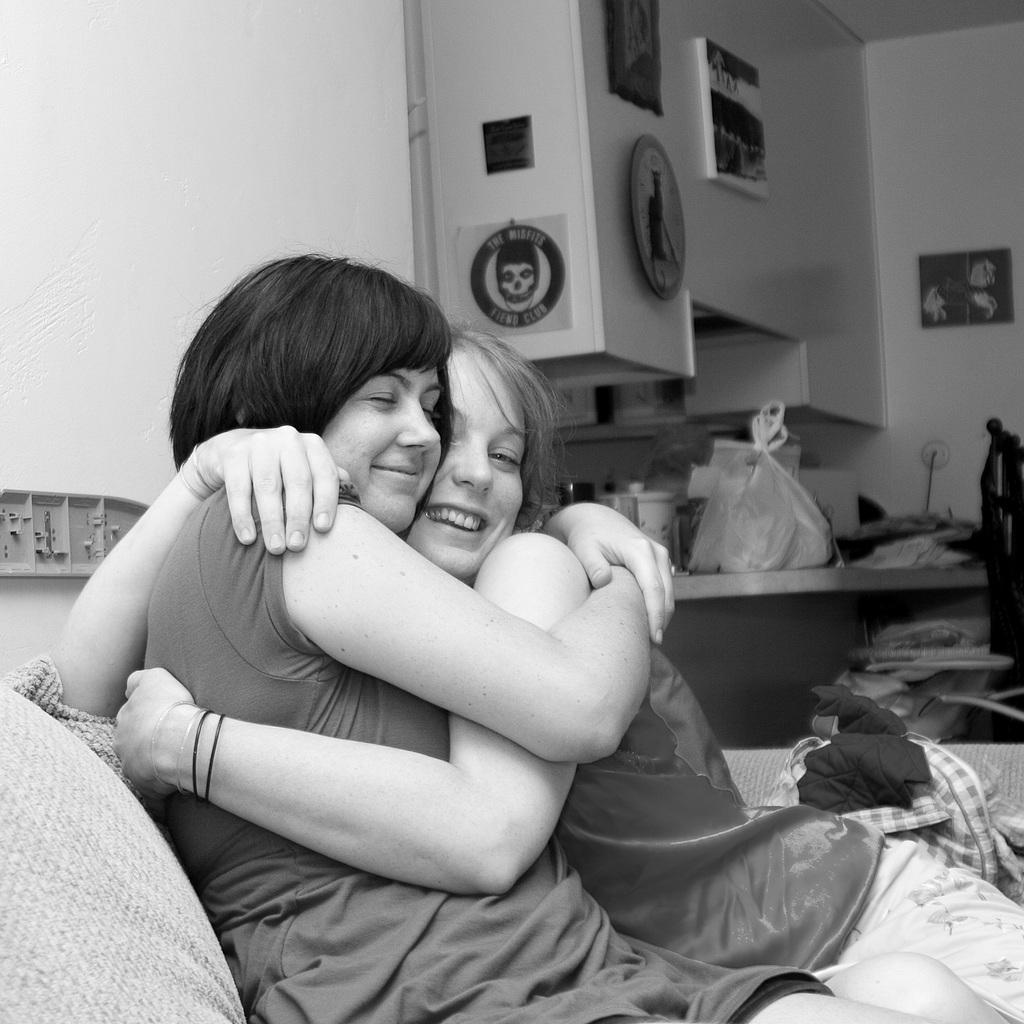What is the main subject of the image? The main subject of the image is a black and white picture of two women. What are the women wearing in the image? The women are wearing clothes in the image. What expression do the women have in the image? The women are smiling in the image. What objects can be seen in the image besides the women? There is a cloth, a cover, a cable wire, and a frame in the image. How is the frame positioned in the image? The frame is stuck to the wall in the image. What type of quiver can be seen in the image? There is no quiver present in the image. What kind of string is attached to the lawyer's briefcase in the image? There is no lawyer or briefcase present in the image. 